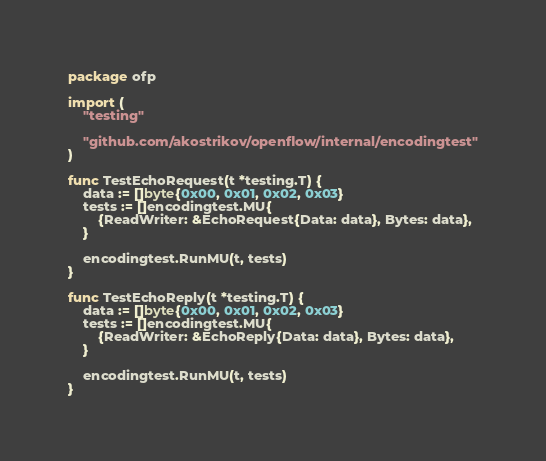<code> <loc_0><loc_0><loc_500><loc_500><_Go_>package ofp

import (
	"testing"

	"github.com/akostrikov/openflow/internal/encodingtest"
)

func TestEchoRequest(t *testing.T) {
	data := []byte{0x00, 0x01, 0x02, 0x03}
	tests := []encodingtest.MU{
		{ReadWriter: &EchoRequest{Data: data}, Bytes: data},
	}

	encodingtest.RunMU(t, tests)
}

func TestEchoReply(t *testing.T) {
	data := []byte{0x00, 0x01, 0x02, 0x03}
	tests := []encodingtest.MU{
		{ReadWriter: &EchoReply{Data: data}, Bytes: data},
	}

	encodingtest.RunMU(t, tests)
}
</code> 